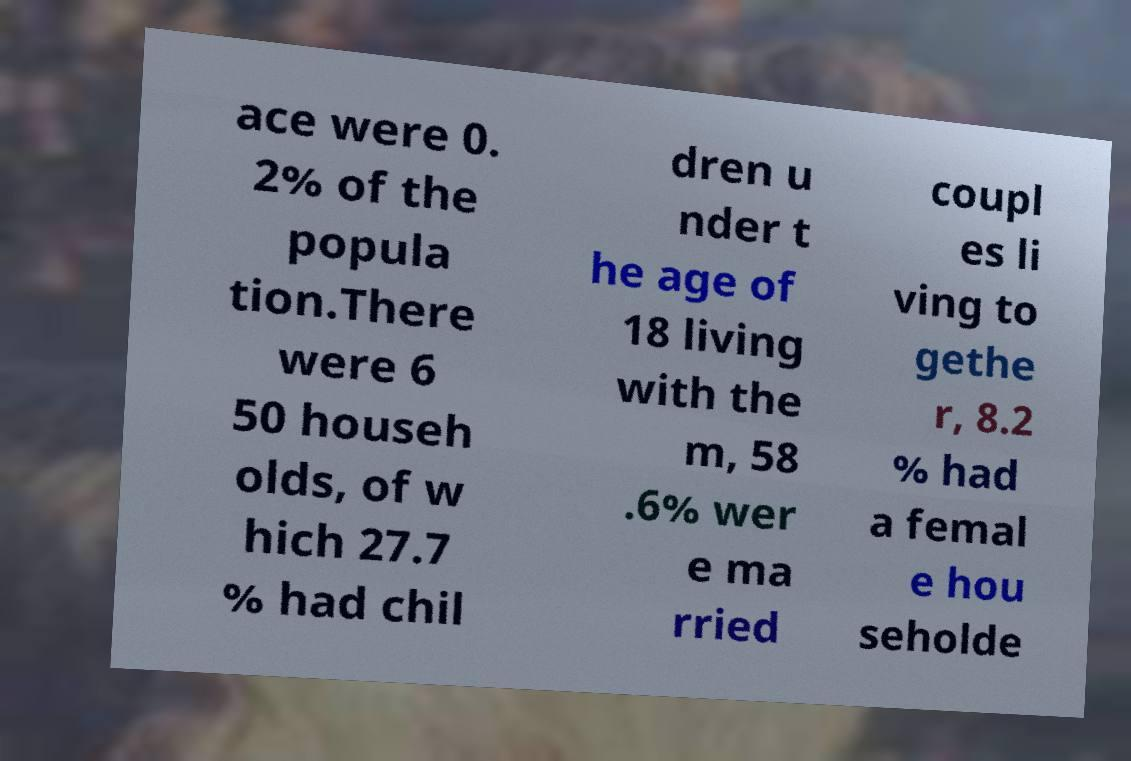Could you extract and type out the text from this image? ace were 0. 2% of the popula tion.There were 6 50 househ olds, of w hich 27.7 % had chil dren u nder t he age of 18 living with the m, 58 .6% wer e ma rried coupl es li ving to gethe r, 8.2 % had a femal e hou seholde 